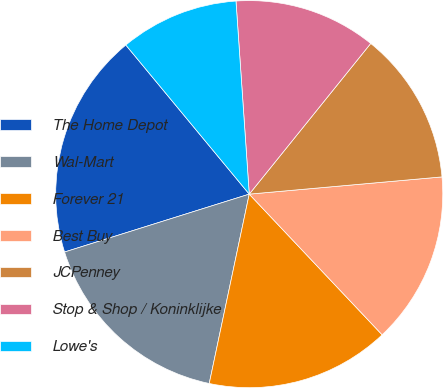<chart> <loc_0><loc_0><loc_500><loc_500><pie_chart><fcel>The Home Depot<fcel>Wal-Mart<fcel>Forever 21<fcel>Best Buy<fcel>JCPenney<fcel>Stop & Shop / Koninklijke<fcel>Lowe's<nl><fcel>18.83%<fcel>16.85%<fcel>15.36%<fcel>14.37%<fcel>12.78%<fcel>11.89%<fcel>9.91%<nl></chart> 